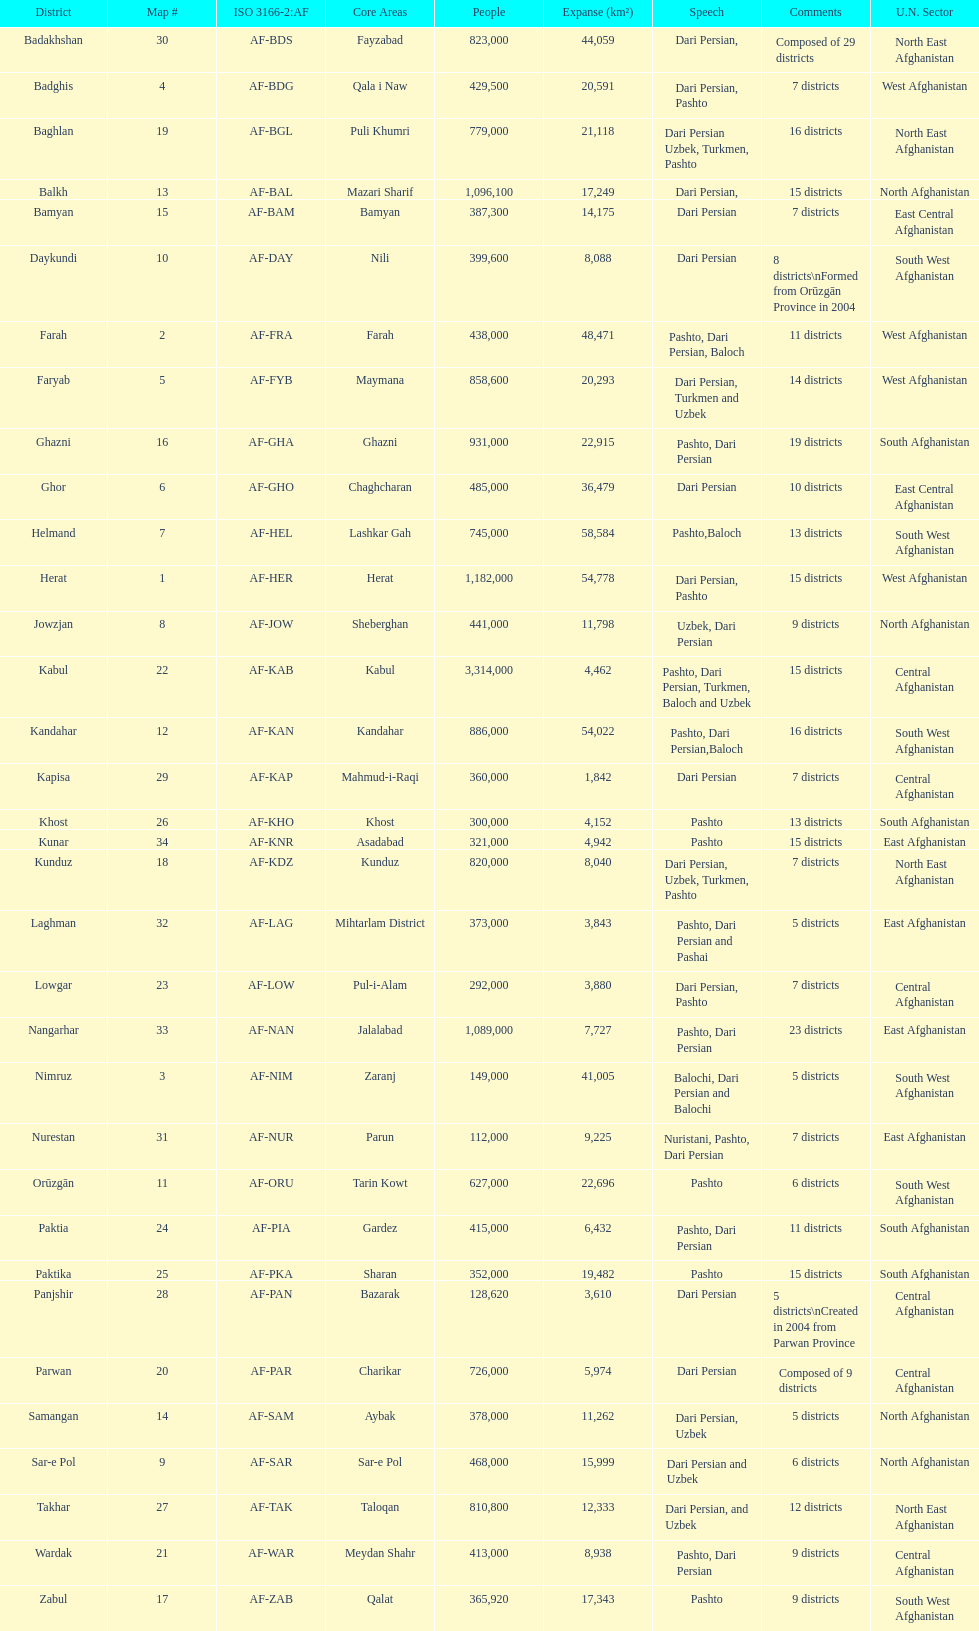Give the province with the least population Nurestan. 